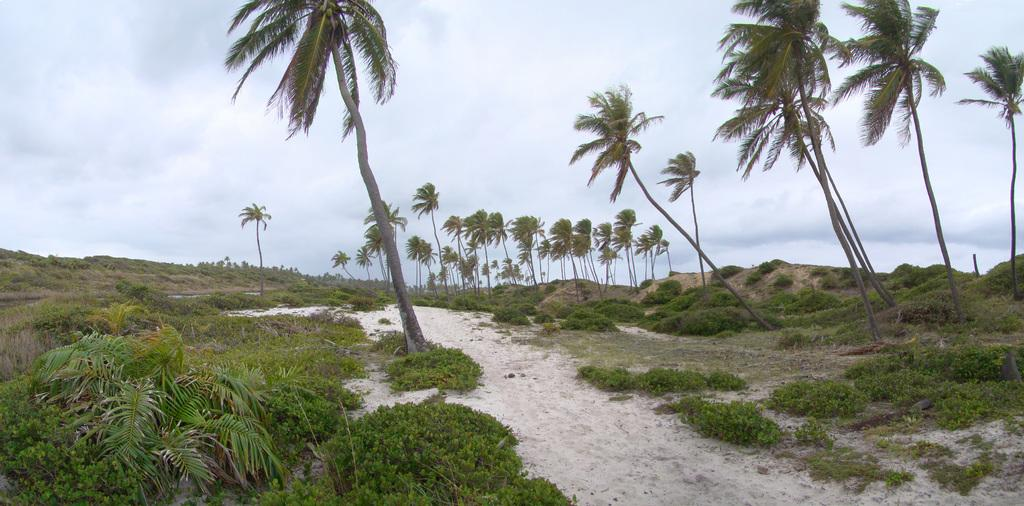What type of vegetation can be seen in the image? There are trees in the image. What kind of surface is visible in the image? There is a path in the image. What is the ground covered with in the image? There is grass in the image. What can be seen in the background of the image? The sky is visible in the background of the image. What is the condition of the sky in the image? Clouds are present in the sky. How many geese are grazing on the beef in the image? There are no geese or beef present in the image. What type of clothing are the women wearing in the image? There are no women present in the image. 